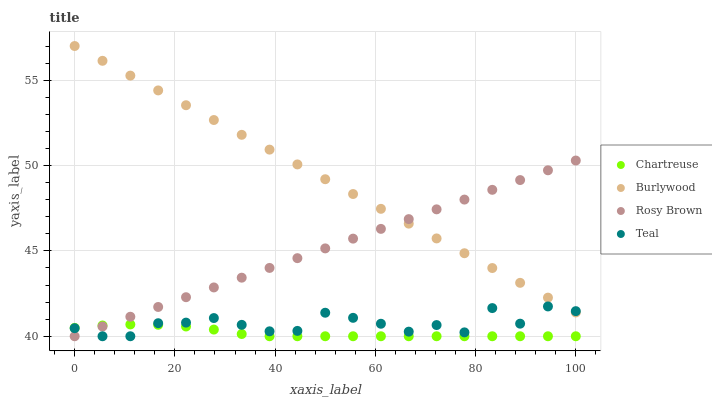Does Chartreuse have the minimum area under the curve?
Answer yes or no. Yes. Does Burlywood have the maximum area under the curve?
Answer yes or no. Yes. Does Rosy Brown have the minimum area under the curve?
Answer yes or no. No. Does Rosy Brown have the maximum area under the curve?
Answer yes or no. No. Is Rosy Brown the smoothest?
Answer yes or no. Yes. Is Teal the roughest?
Answer yes or no. Yes. Is Chartreuse the smoothest?
Answer yes or no. No. Is Chartreuse the roughest?
Answer yes or no. No. Does Chartreuse have the lowest value?
Answer yes or no. Yes. Does Burlywood have the highest value?
Answer yes or no. Yes. Does Rosy Brown have the highest value?
Answer yes or no. No. Is Chartreuse less than Burlywood?
Answer yes or no. Yes. Is Burlywood greater than Chartreuse?
Answer yes or no. Yes. Does Rosy Brown intersect Teal?
Answer yes or no. Yes. Is Rosy Brown less than Teal?
Answer yes or no. No. Is Rosy Brown greater than Teal?
Answer yes or no. No. Does Chartreuse intersect Burlywood?
Answer yes or no. No. 